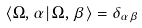<formula> <loc_0><loc_0><loc_500><loc_500>\langle \Omega , \alpha | \, \Omega , \beta \rangle = \delta _ { \alpha \beta }</formula> 